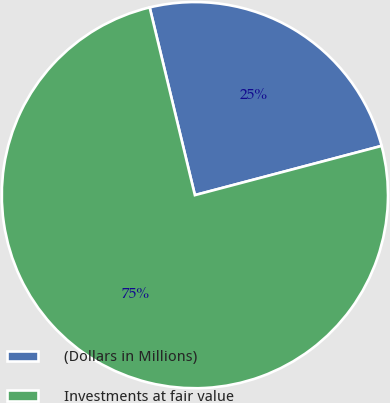Convert chart to OTSL. <chart><loc_0><loc_0><loc_500><loc_500><pie_chart><fcel>(Dollars in Millions)<fcel>Investments at fair value<nl><fcel>24.66%<fcel>75.34%<nl></chart> 